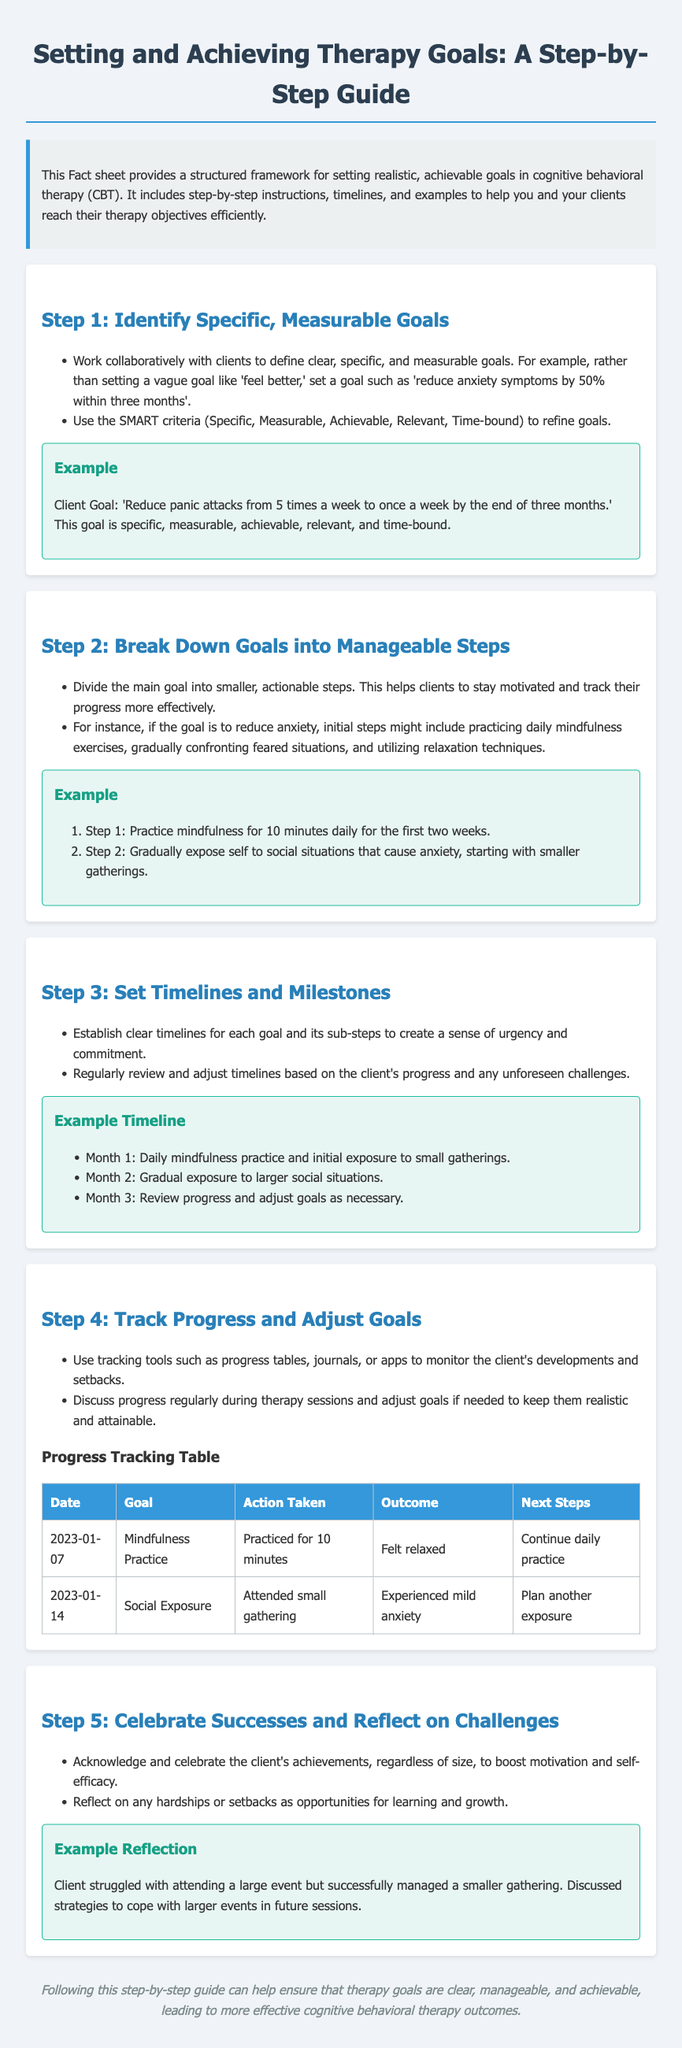What is the title of the document? The title is provided at the top of the document, which outlines the main subject of the fact sheet.
Answer: Setting and Achieving Therapy Goals: A Step-by-Step Guide What does SMART stand for? The SMART criteria help in refining clear goals; the acronym stands for Specific, Measurable, Achievable, Relevant, Time-bound.
Answer: Specific, Measurable, Achievable, Relevant, Time-bound How many months is the example timeline set for? The timeline spans three months as outlined in the example.
Answer: Three months What is the first step in setting therapy goals? The first step mentioned is to identify specific, measurable goals, a crucial part of the goal-setting process in therapy.
Answer: Identify Specific, Measurable Goals What does the progress tracking table include? The table is to monitor goals and includes several columns for capturing different details regarding progress and actions.
Answer: Date, Goal, Action Taken, Outcome, Next Steps By how much should panic attacks be reduced according to the example goal? The example goal specifically states the target for reducing panic attacks within a set timeframe.
Answer: from 5 times a week to once a week What is encouraged after a client achieves their goals? Celebrating successes regardless of their size is emphasized as a way to promote motivation and self-efficacy.
Answer: Celebrate Successes What is the focus of the document type? The focus is to provide a structured framework for setting realistic and achievable therapy goals.
Answer: Therapy goals 